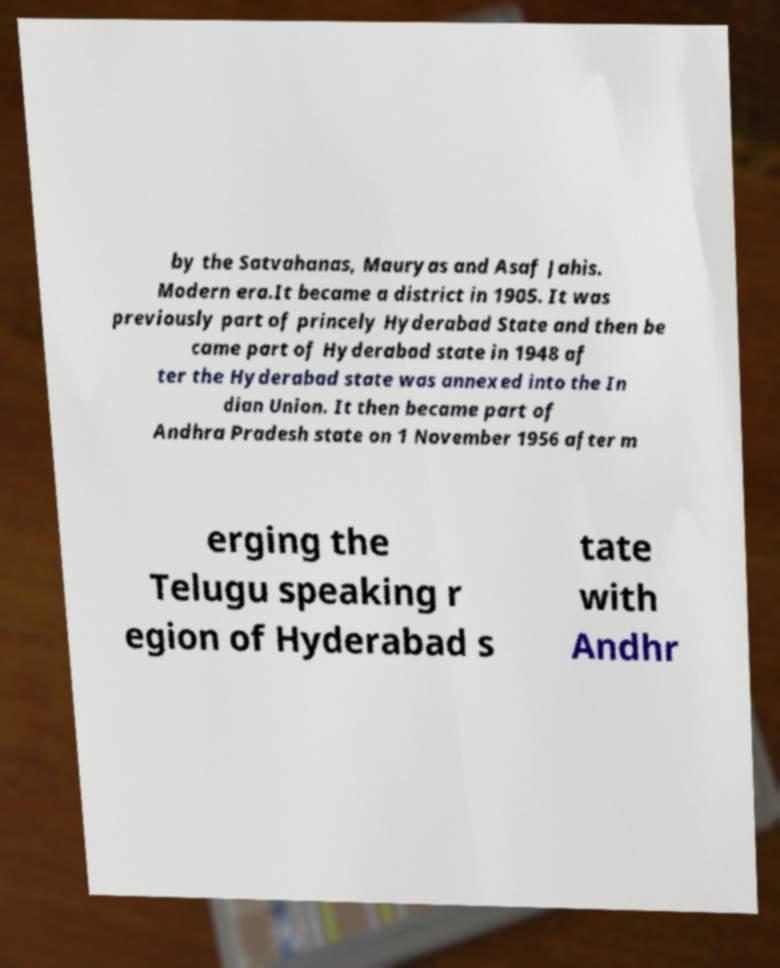There's text embedded in this image that I need extracted. Can you transcribe it verbatim? by the Satvahanas, Mauryas and Asaf Jahis. Modern era.It became a district in 1905. It was previously part of princely Hyderabad State and then be came part of Hyderabad state in 1948 af ter the Hyderabad state was annexed into the In dian Union. It then became part of Andhra Pradesh state on 1 November 1956 after m erging the Telugu speaking r egion of Hyderabad s tate with Andhr 